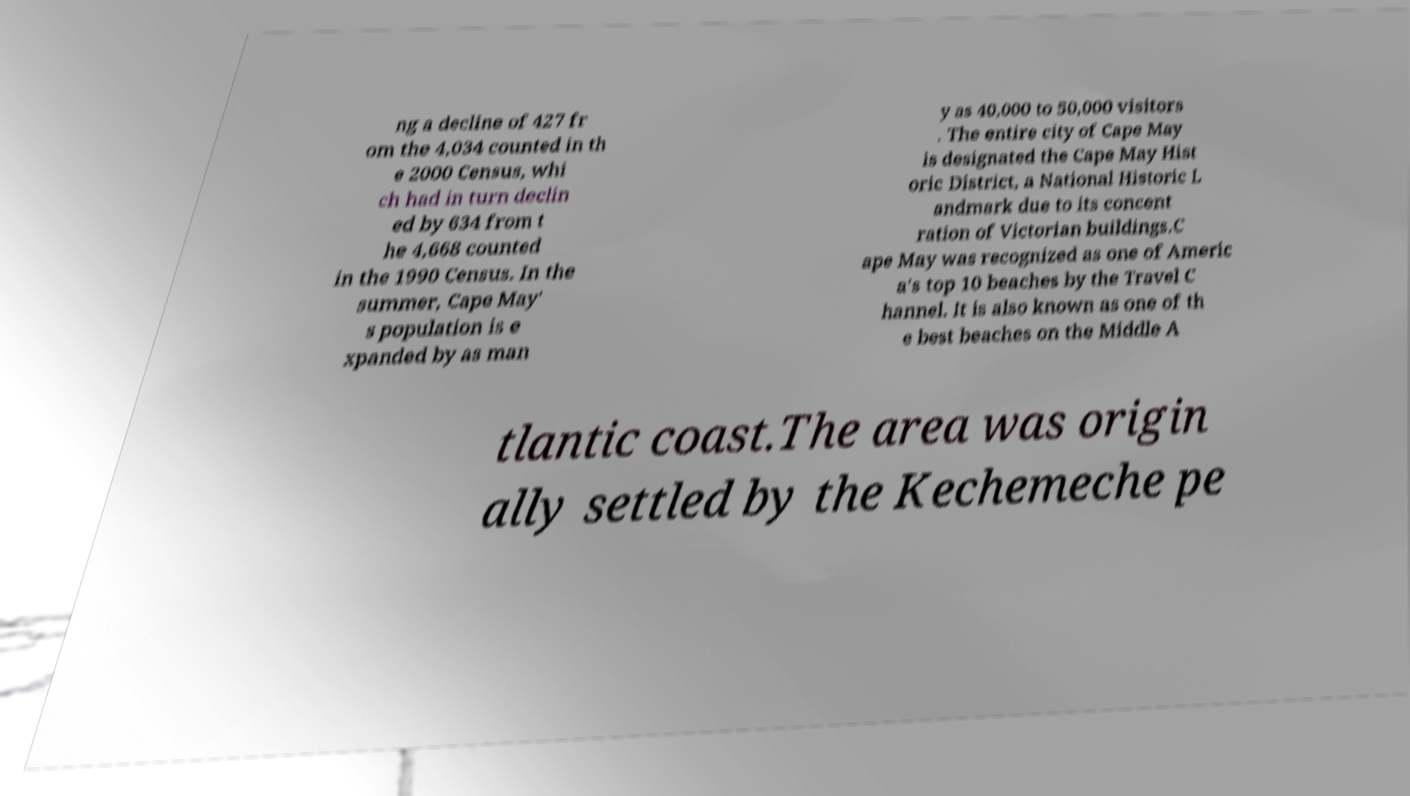There's text embedded in this image that I need extracted. Can you transcribe it verbatim? ng a decline of 427 fr om the 4,034 counted in th e 2000 Census, whi ch had in turn declin ed by 634 from t he 4,668 counted in the 1990 Census. In the summer, Cape May' s population is e xpanded by as man y as 40,000 to 50,000 visitors . The entire city of Cape May is designated the Cape May Hist oric District, a National Historic L andmark due to its concent ration of Victorian buildings.C ape May was recognized as one of Americ a's top 10 beaches by the Travel C hannel. It is also known as one of th e best beaches on the Middle A tlantic coast.The area was origin ally settled by the Kechemeche pe 